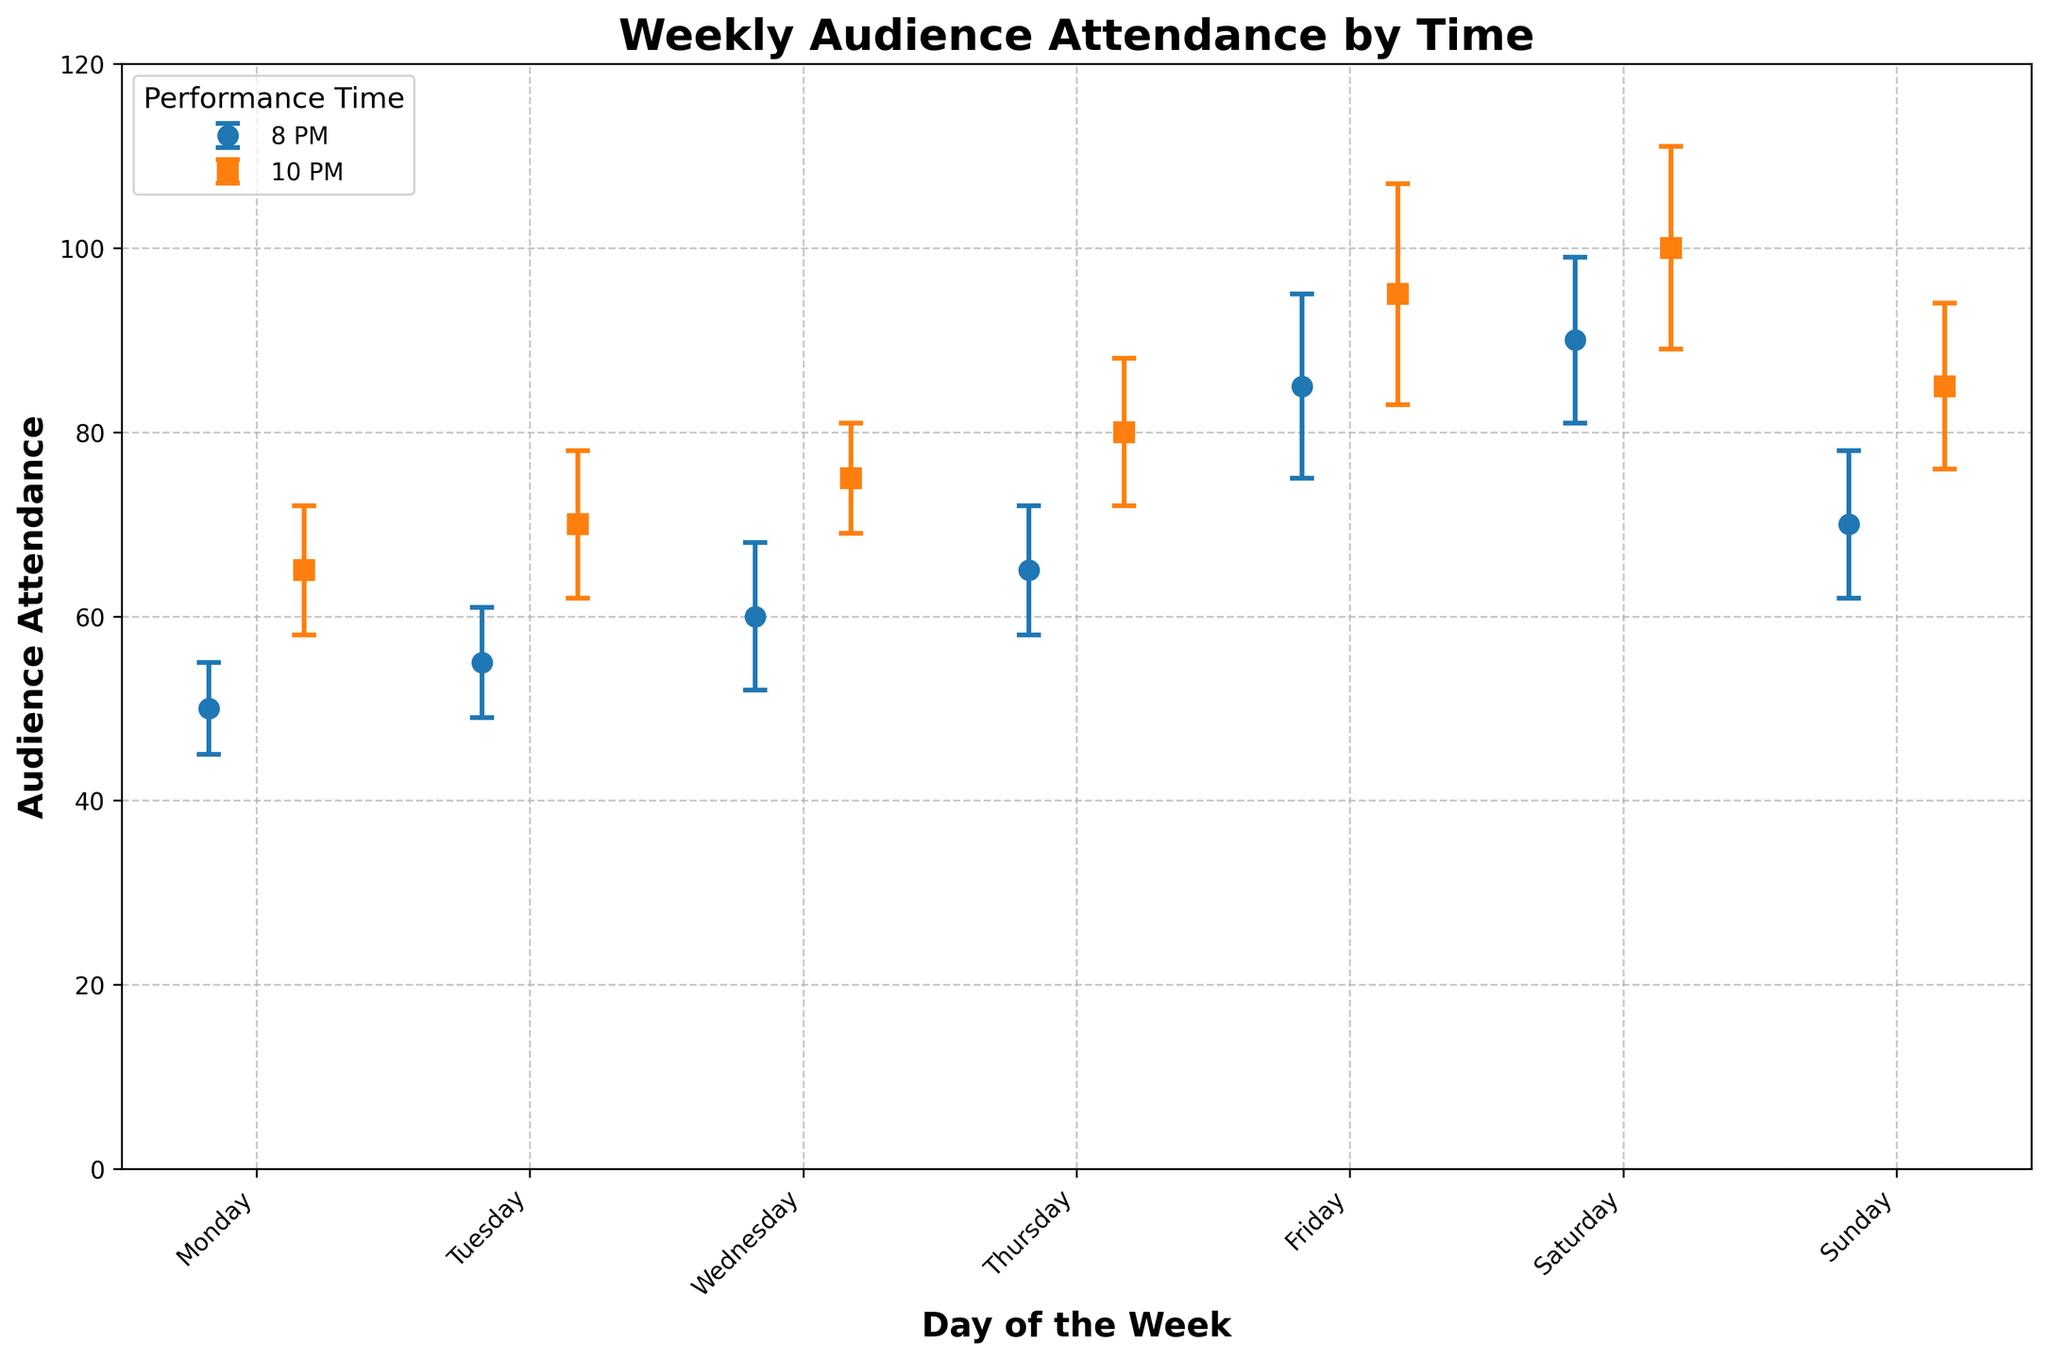What's the title of the plot? The title of the plot is written at the top of the figure, and it is usually in a larger and bolder font. Here, it reads "Weekly Audience Attendance by Time".
Answer: Weekly Audience Attendance by Time What is the general trend of attendance from Monday to Sunday for the performance at 8 PM? By examining the bars corresponding to the 8 PM time slot for each day, we can observe their heights. The attendance generally increases from Monday to Saturday and then decreases slightly on Sunday.
Answer: Increasing, then slight decrease on Sunday Which day of the week has the highest audience attendance at 10 PM? We can look at the bar heights for the 10 PM slots. The highest bar indicates the highest attendance. The attendance is highest on Saturday at 10 PM.
Answer: Saturday How does the standard deviation of audience attendance at 10 PM on Friday compare to that on Saturday? By examining the error bars for the 10 PM slot on both Friday and Saturday, we can see that the length of the error bar (standard deviation) on Friday is slightly longer than that on Saturday.
Answer: Friday has higher standard deviation What's the difference in audience attendance between 8 PM and 10 PM on Wednesday? The attendance at 8 PM on Wednesday is 60, while at 10 PM, it is 75. To find the difference, subtract 60 from 75.
Answer: 15 Which day has the least variation in audience attendance for the 8 PM performance? The variation in attendance is indicated by the error bars (standard deviation). The shortest error bar for the 8 PM slot indicates the least variation, which is on Monday with a standard deviation of 5.
Answer: Monday What is the average attendance on a Tuesday? The attendance on Tuesday at 8 PM is 55, and at 10 PM it is 70. To find the average, add the two values (55 + 70) and divide by 2.
Answer: 62.5 What is the total attendance for the 8 PM performances over the week? Sum the attendance values for the 8 PM slot from Monday to Sunday: 50 + 55 + 60 + 65 + 85 + 90 + 70. The total is 475.
Answer: 475 On which day is the discrepancy between 8 PM and 10 PM attendance the smallest? To find the smallest discrepancy, we subtract the 8 PM attendance from the 10 PM attendance for each day and compare the results. The smallest difference is on Sunday (85 - 70 = 15).
Answer: Sunday Is there a time of day generally preferred by audiences on weekends (Friday, Saturday, Sunday)? Comparing attendance values for Friday, Saturday, and Sunday at both 8 PM and 10 PM, we see that in all three cases, the attendance is higher at 10 PM than at 8 PM. This suggests a general preference for 10 PM performances on the weekends.
Answer: 10 PM 